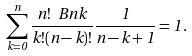<formula> <loc_0><loc_0><loc_500><loc_500>\sum _ { k = 0 } ^ { n } \frac { n ! \ B n { k } } { k ! ( n - k ) ! } \frac { 1 } { n - k + 1 } = 1 \, .</formula> 